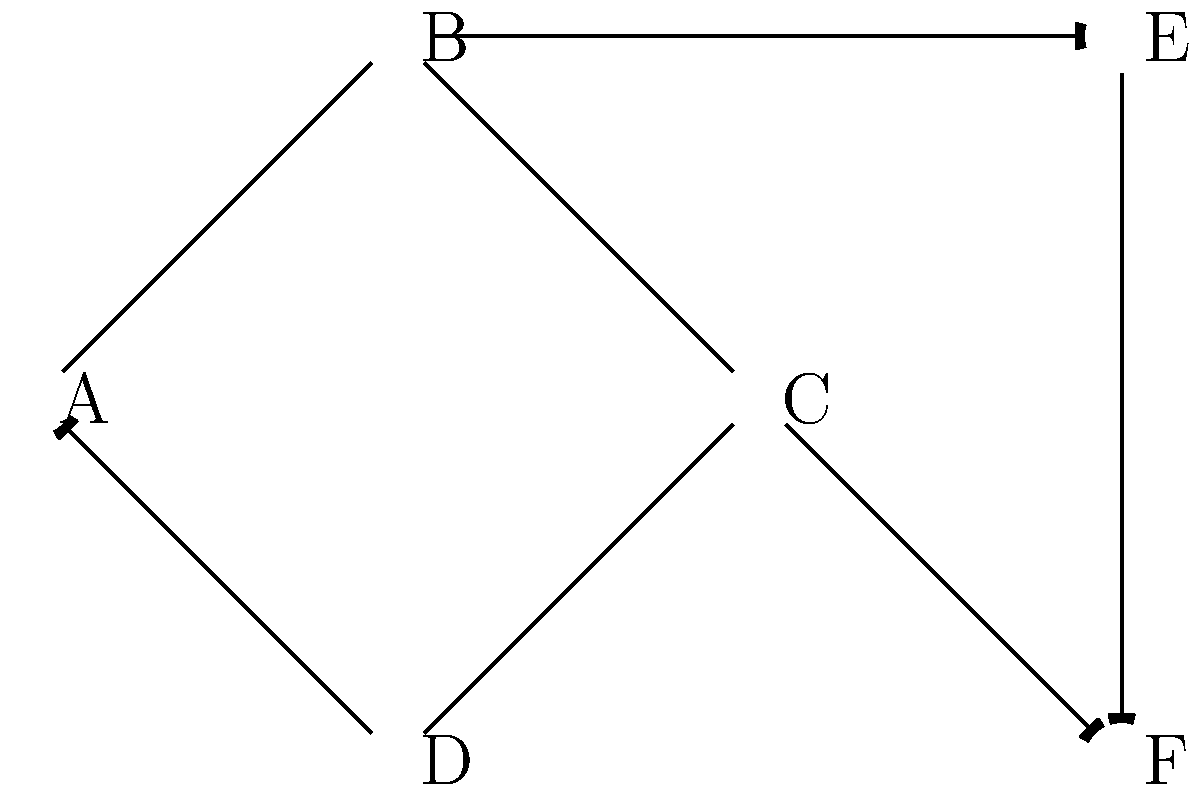Consider the network topology shown above for distributed AI processing of historical documents. Each node represents a processing unit, and edges represent data flow. If the goal is to minimize latency while maximizing throughput, which node should be designated as the central coordinator for load balancing and task distribution? To determine the optimal central coordinator for load balancing and task distribution, we need to consider several factors:

1. Centrality: The node should have a central position in the network to minimize communication latency.
2. Connectivity: The node should have direct connections to as many other nodes as possible.
3. Access to input and output: The node should be well-positioned to receive input data and distribute processed results.

Let's analyze each node:

A: Connected to 3 nodes (B, C, D), but not central.
B: Connected to 3 nodes (A, C, E), more central position.
C: Connected to 4 nodes (A, B, D, F), most connections and central.
D: Connected to 2 nodes (A, C), not central.
E: Connected to 2 nodes (B, F), on the periphery.
F: Connected to 2 nodes (C, E), on the periphery.

Node C has the highest connectivity (4 connections) and is centrally located. It can efficiently receive input from nodes A and D, process and distribute tasks to B and F, and collect results from all connected nodes.

Additionally, C's position allows it to act as a bridge between the two halves of the network (A-B-E and D-F), facilitating efficient data flow and load balancing across the entire system.
Answer: Node C 